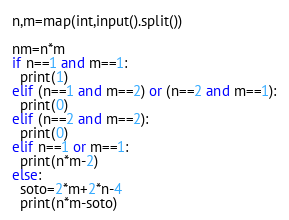Convert code to text. <code><loc_0><loc_0><loc_500><loc_500><_Python_>n,m=map(int,input().split())

nm=n*m
if n==1 and m==1:
  print(1)
elif (n==1 and m==2) or (n==2 and m==1):
  print(0)
elif (n==2 and m==2):
  print(0)
elif n==1 or m==1:
  print(n*m-2)
else:
  soto=2*m+2*n-4
  print(n*m-soto)
</code> 